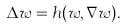Convert formula to latex. <formula><loc_0><loc_0><loc_500><loc_500>\Delta w = h ( w , \nabla w ) .</formula> 